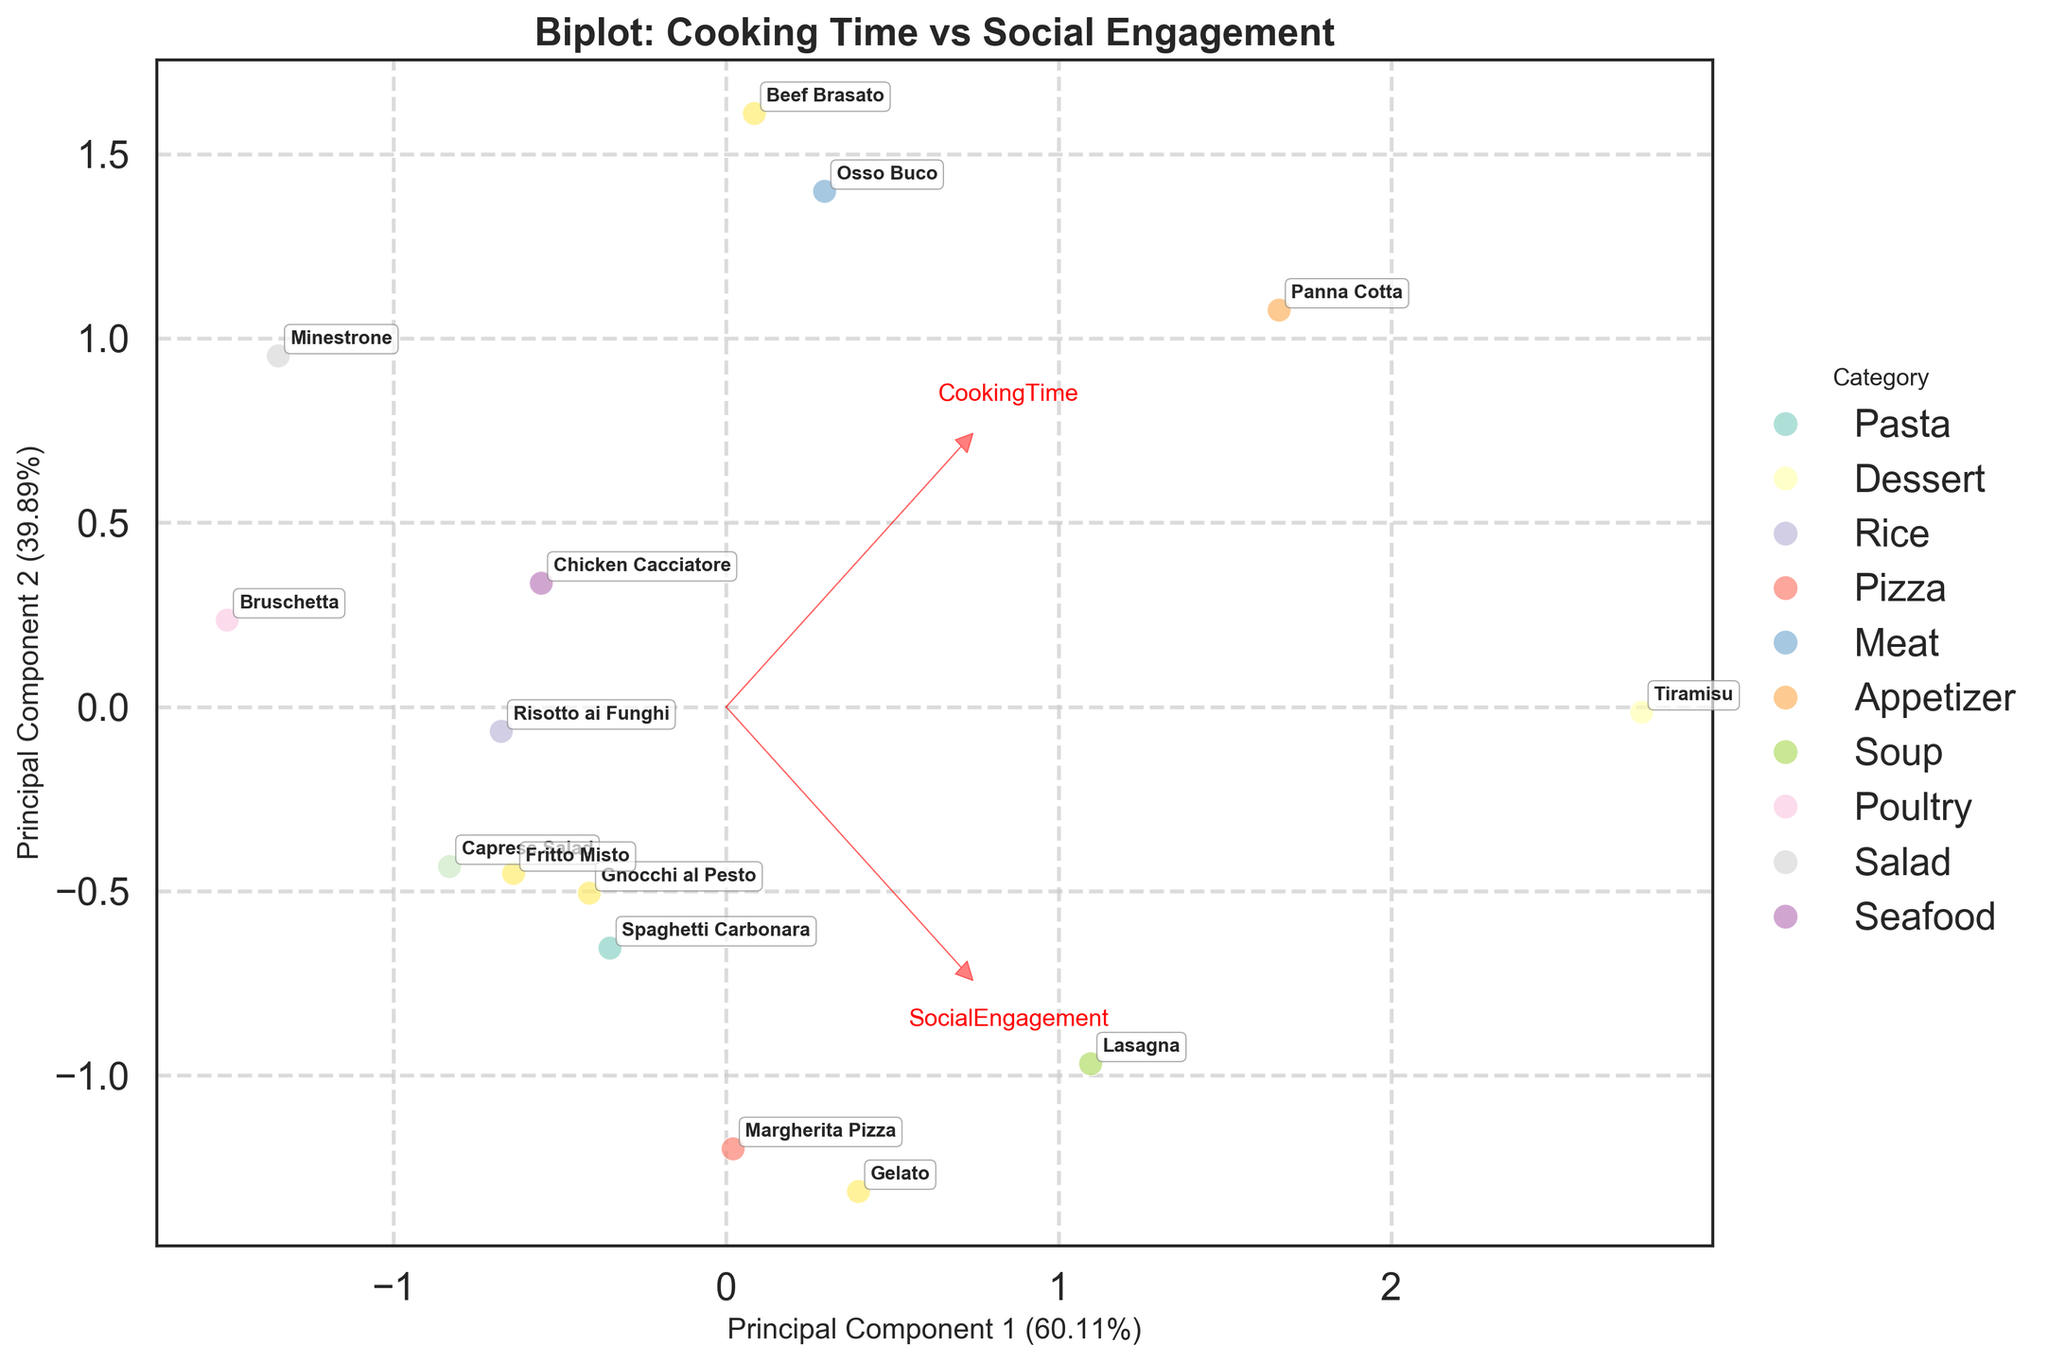What is the title of the plot? The title is usually placed at the top of the figure and represents the general purpose or subject of the plot. By looking at the top of the figure, you can see the text that specifies the title.
Answer: Biplot: Cooking Time vs Social Engagement What are the two features shown by the vectors in the plot? By observing the arrows (feature vectors) presented in the figure, you will see labels at their tips. These labels usually indicate the names of the features being represented.
Answer: CookingTime and SocialEngagement Which recipe shows the highest social engagement based on the plot? Locate the data point corresponding to the highest value on the SocialEngagement vector. The label near this point indicates the recipe with the highest social engagement.
Answer: Tiramisu Which category appears most frequently in the plot? By examining the colors and the legend on the right side of the plot, you can count the number of data points for each category. The category with the highest count is the most frequent.
Answer: Pasta Are the principal components labeled in the plot? Typically, the principal components are labeled on the X and Y axes of the plot. Look for descriptions like "Principal Component 1" and "Principal Component 2" along the respective axes.
Answer: Yes Which recipe has the shortest cooking time and where is it located on the plot? Identify the data point with the shortest cooking time by looking at the vector labeled "CookingTime" and finding the point closest to the origin in that direction. The label next to this point will indicate the recipe.
Answer: Bruschetta How many components did the PCA reduce the data to? The number of principal components depicted in the plot is indicated by the two axes labels, "Principal Component 1" and "Principal Component 2". Hence, the PCA reduced the data to these two components.
Answer: 2 Which two categories appear closest to each other on the plot, suggesting similar cooking time and social engagement? Look for two sets of points that are near to each other and examine their category colors or labels. The proximity of these points indicates similarity in the two features.
Answer: Appetizer and Salad 